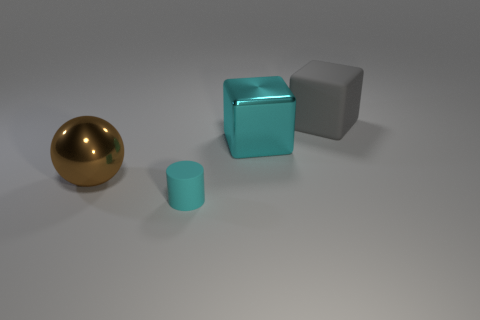Add 1 big cyan rubber cylinders. How many objects exist? 5 Subtract all cylinders. How many objects are left? 3 Add 3 big matte objects. How many big matte objects exist? 4 Subtract 0 red balls. How many objects are left? 4 Subtract all large cyan things. Subtract all matte cylinders. How many objects are left? 2 Add 1 gray cubes. How many gray cubes are left? 2 